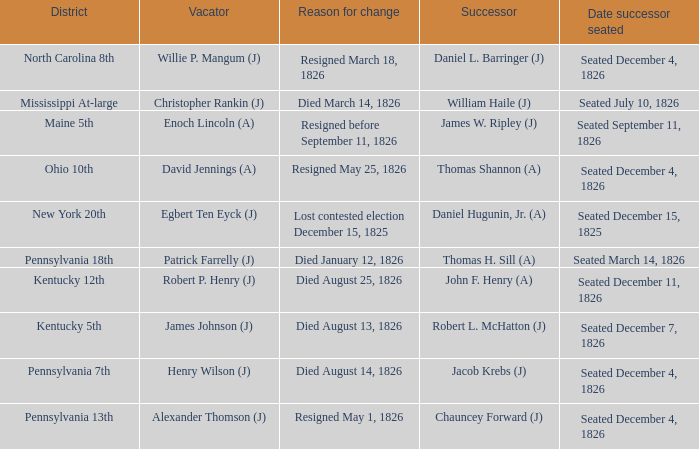Name the reason for change pennsylvania 13th Resigned May 1, 1826. Could you help me parse every detail presented in this table? {'header': ['District', 'Vacator', 'Reason for change', 'Successor', 'Date successor seated'], 'rows': [['North Carolina 8th', 'Willie P. Mangum (J)', 'Resigned March 18, 1826', 'Daniel L. Barringer (J)', 'Seated December 4, 1826'], ['Mississippi At-large', 'Christopher Rankin (J)', 'Died March 14, 1826', 'William Haile (J)', 'Seated July 10, 1826'], ['Maine 5th', 'Enoch Lincoln (A)', 'Resigned before September 11, 1826', 'James W. Ripley (J)', 'Seated September 11, 1826'], ['Ohio 10th', 'David Jennings (A)', 'Resigned May 25, 1826', 'Thomas Shannon (A)', 'Seated December 4, 1826'], ['New York 20th', 'Egbert Ten Eyck (J)', 'Lost contested election December 15, 1825', 'Daniel Hugunin, Jr. (A)', 'Seated December 15, 1825'], ['Pennsylvania 18th', 'Patrick Farrelly (J)', 'Died January 12, 1826', 'Thomas H. Sill (A)', 'Seated March 14, 1826'], ['Kentucky 12th', 'Robert P. Henry (J)', 'Died August 25, 1826', 'John F. Henry (A)', 'Seated December 11, 1826'], ['Kentucky 5th', 'James Johnson (J)', 'Died August 13, 1826', 'Robert L. McHatton (J)', 'Seated December 7, 1826'], ['Pennsylvania 7th', 'Henry Wilson (J)', 'Died August 14, 1826', 'Jacob Krebs (J)', 'Seated December 4, 1826'], ['Pennsylvania 13th', 'Alexander Thomson (J)', 'Resigned May 1, 1826', 'Chauncey Forward (J)', 'Seated December 4, 1826']]} 